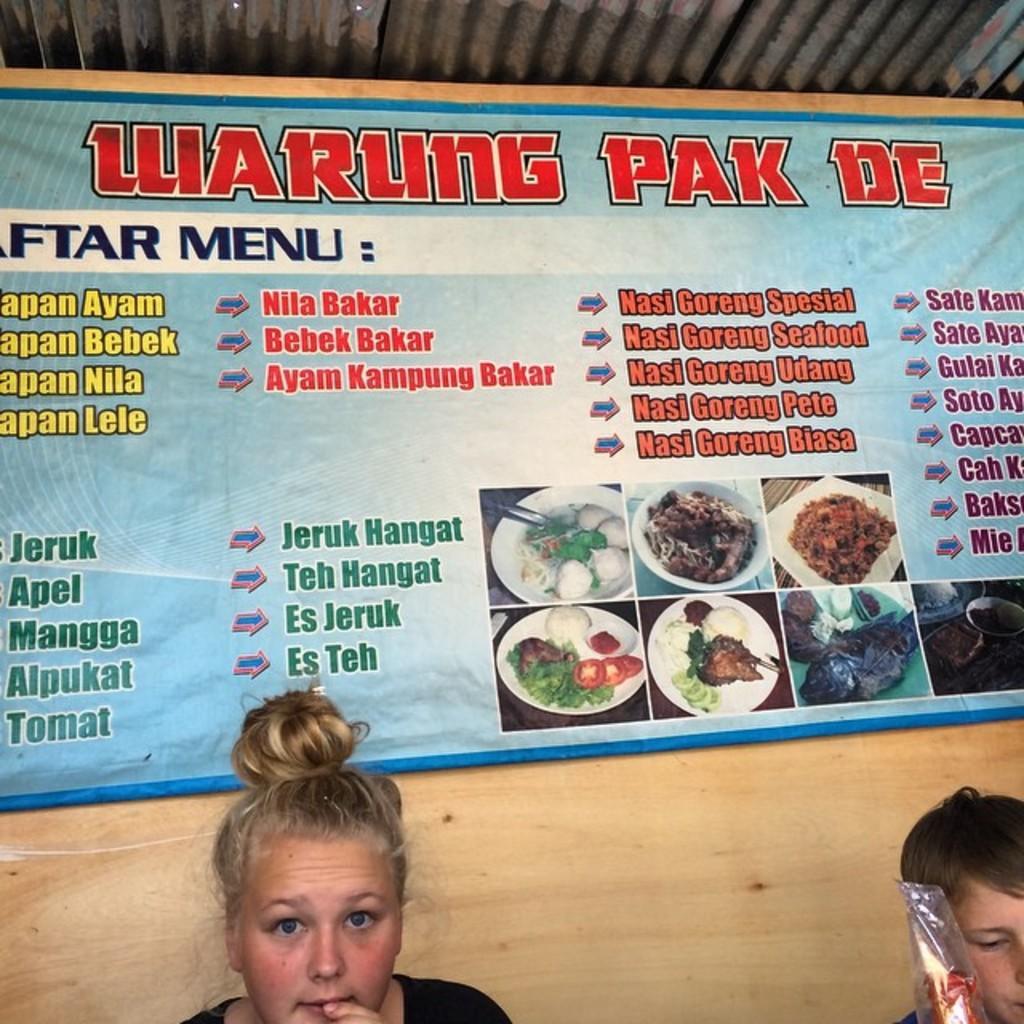Describe this image in one or two sentences. In the image there is a menu banner on the wall with iron sheets above it and below there is a blond haired woman and a boy visible. 